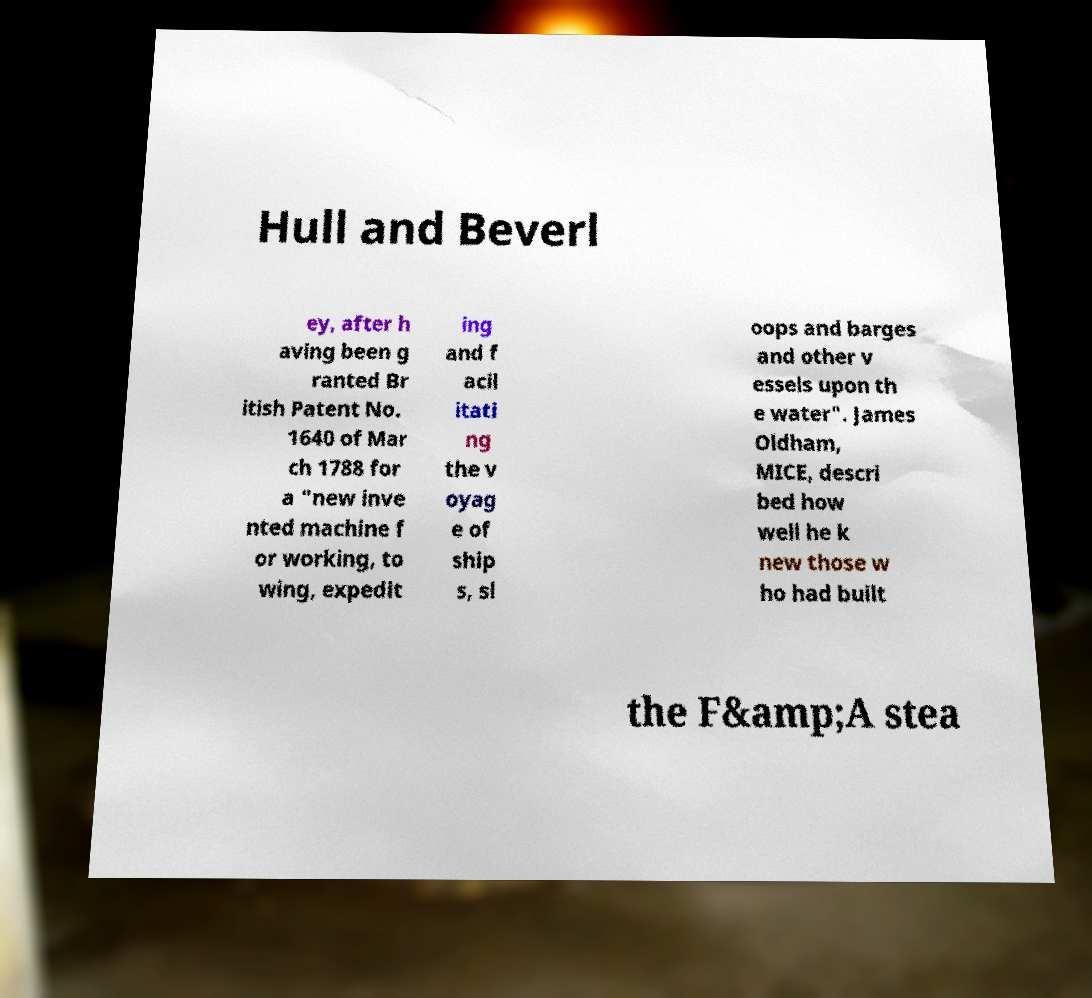Could you extract and type out the text from this image? Hull and Beverl ey, after h aving been g ranted Br itish Patent No. 1640 of Mar ch 1788 for a "new inve nted machine f or working, to wing, expedit ing and f acil itati ng the v oyag e of ship s, sl oops and barges and other v essels upon th e water". James Oldham, MICE, descri bed how well he k new those w ho had built the F&amp;A stea 